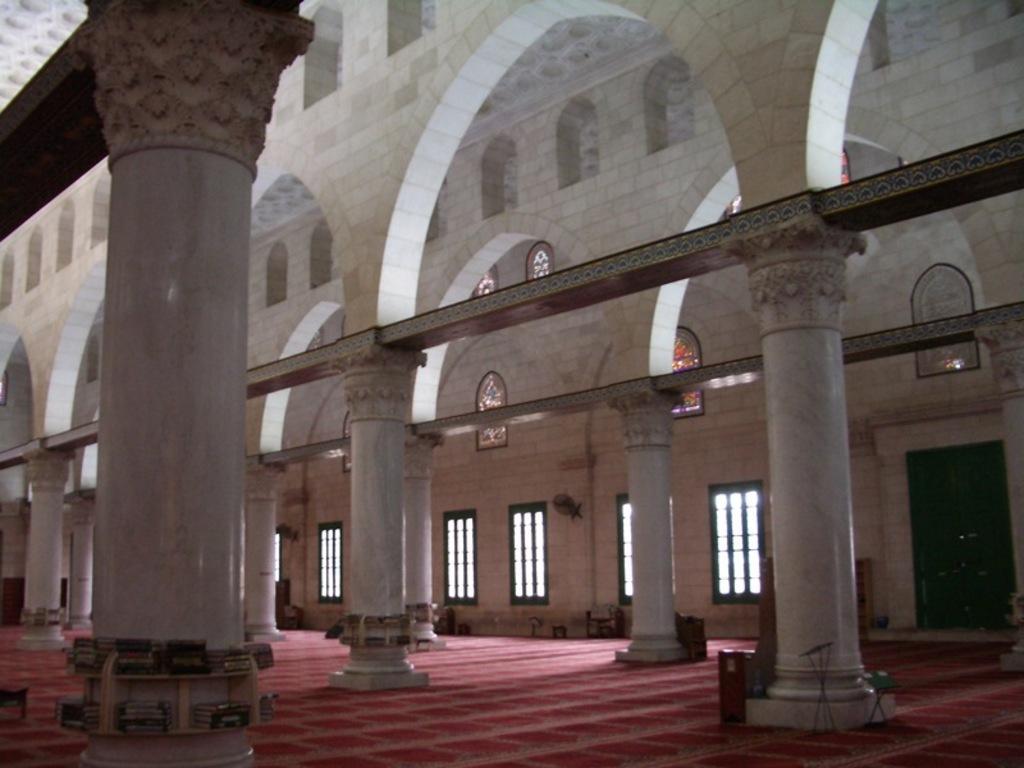Please provide a concise description of this image. This image is taken inside the building, where we can see there are pillars in the middle. At the top there are walls. In the background there are windows. On the right side there is a door. At the bottom there is floor. 